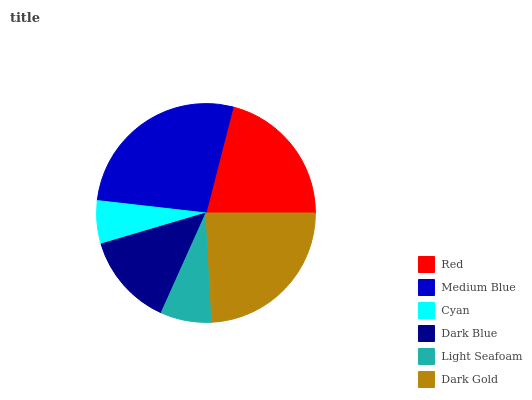Is Cyan the minimum?
Answer yes or no. Yes. Is Medium Blue the maximum?
Answer yes or no. Yes. Is Medium Blue the minimum?
Answer yes or no. No. Is Cyan the maximum?
Answer yes or no. No. Is Medium Blue greater than Cyan?
Answer yes or no. Yes. Is Cyan less than Medium Blue?
Answer yes or no. Yes. Is Cyan greater than Medium Blue?
Answer yes or no. No. Is Medium Blue less than Cyan?
Answer yes or no. No. Is Red the high median?
Answer yes or no. Yes. Is Dark Blue the low median?
Answer yes or no. Yes. Is Medium Blue the high median?
Answer yes or no. No. Is Red the low median?
Answer yes or no. No. 